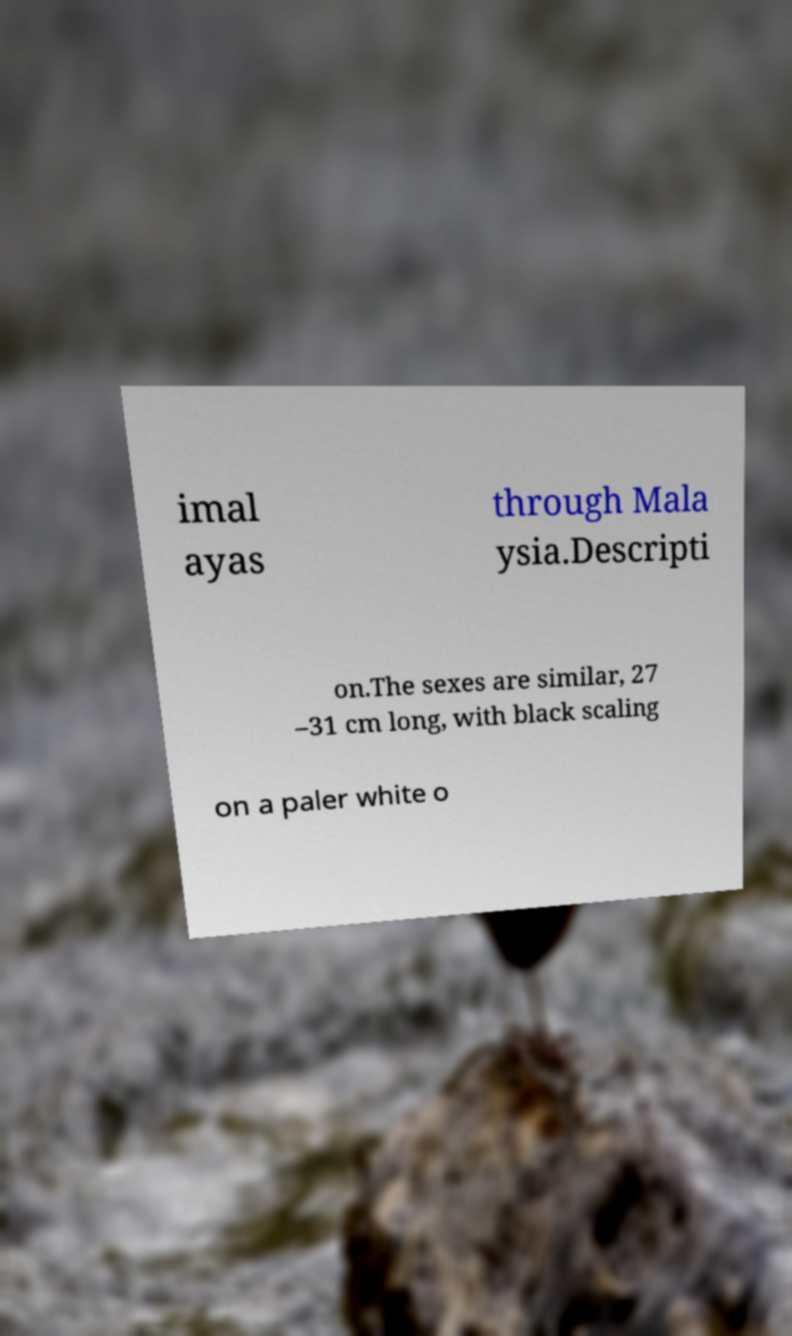Could you assist in decoding the text presented in this image and type it out clearly? imal ayas through Mala ysia.Descripti on.The sexes are similar, 27 –31 cm long, with black scaling on a paler white o 